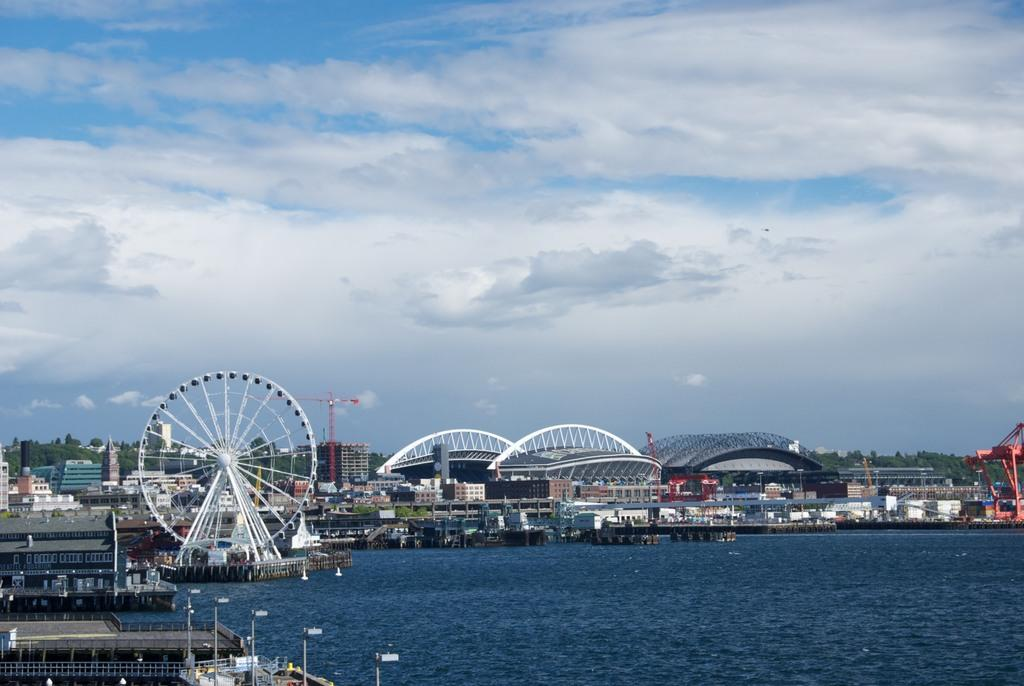What is the main feature in the foreground of the image? There is a lake in the foreground of the image. What is visible in the background of the image? There is a Ferris wheel, buildings, a group of trees, and a cloudy sky in the background of the image. Can you describe the Ferris wheel in the image? The Ferris wheel is located in the background of the image. What type of vegetation can be seen in the background of the image? There is a group of trees in the background of the image. What type of birthday celebration is taking place near the lake in the image? There is no indication of a birthday celebration in the image; it simply features a lake and various background elements. 